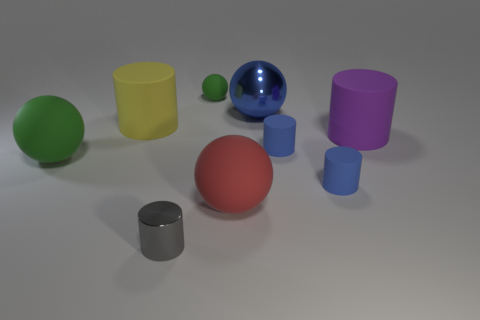Among the objects present, which one looks the shiniest? The shiniest object in the image appears to be the large blue sphere, which exhibits a reflective, glossy finish and distinct highlights, indicating a smooth and highly polished surface. 